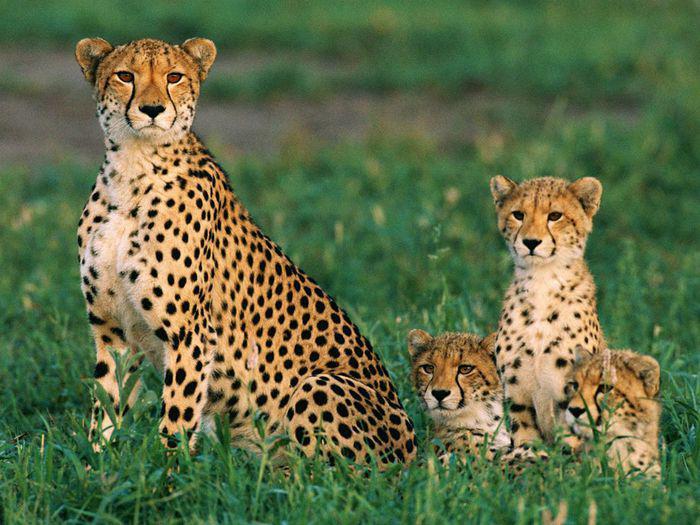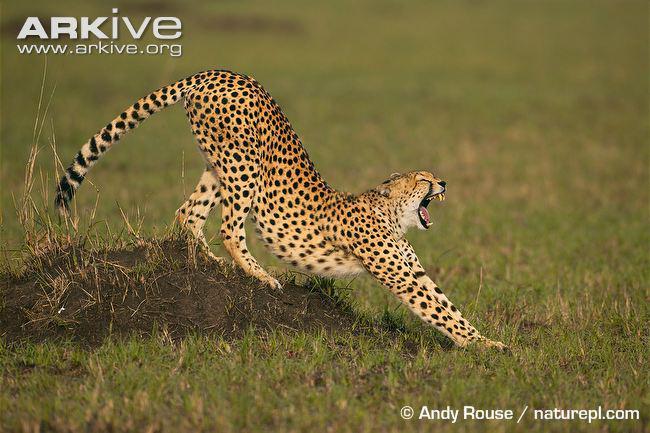The first image is the image on the left, the second image is the image on the right. Considering the images on both sides, is "Exactly three cheetahs are shown, with two in one image sedentary, and the third in the other image running with its front paws off the ground." valid? Answer yes or no. No. The first image is the image on the left, the second image is the image on the right. For the images shown, is this caption "Several animals are in a grassy are in the image on the left." true? Answer yes or no. Yes. 